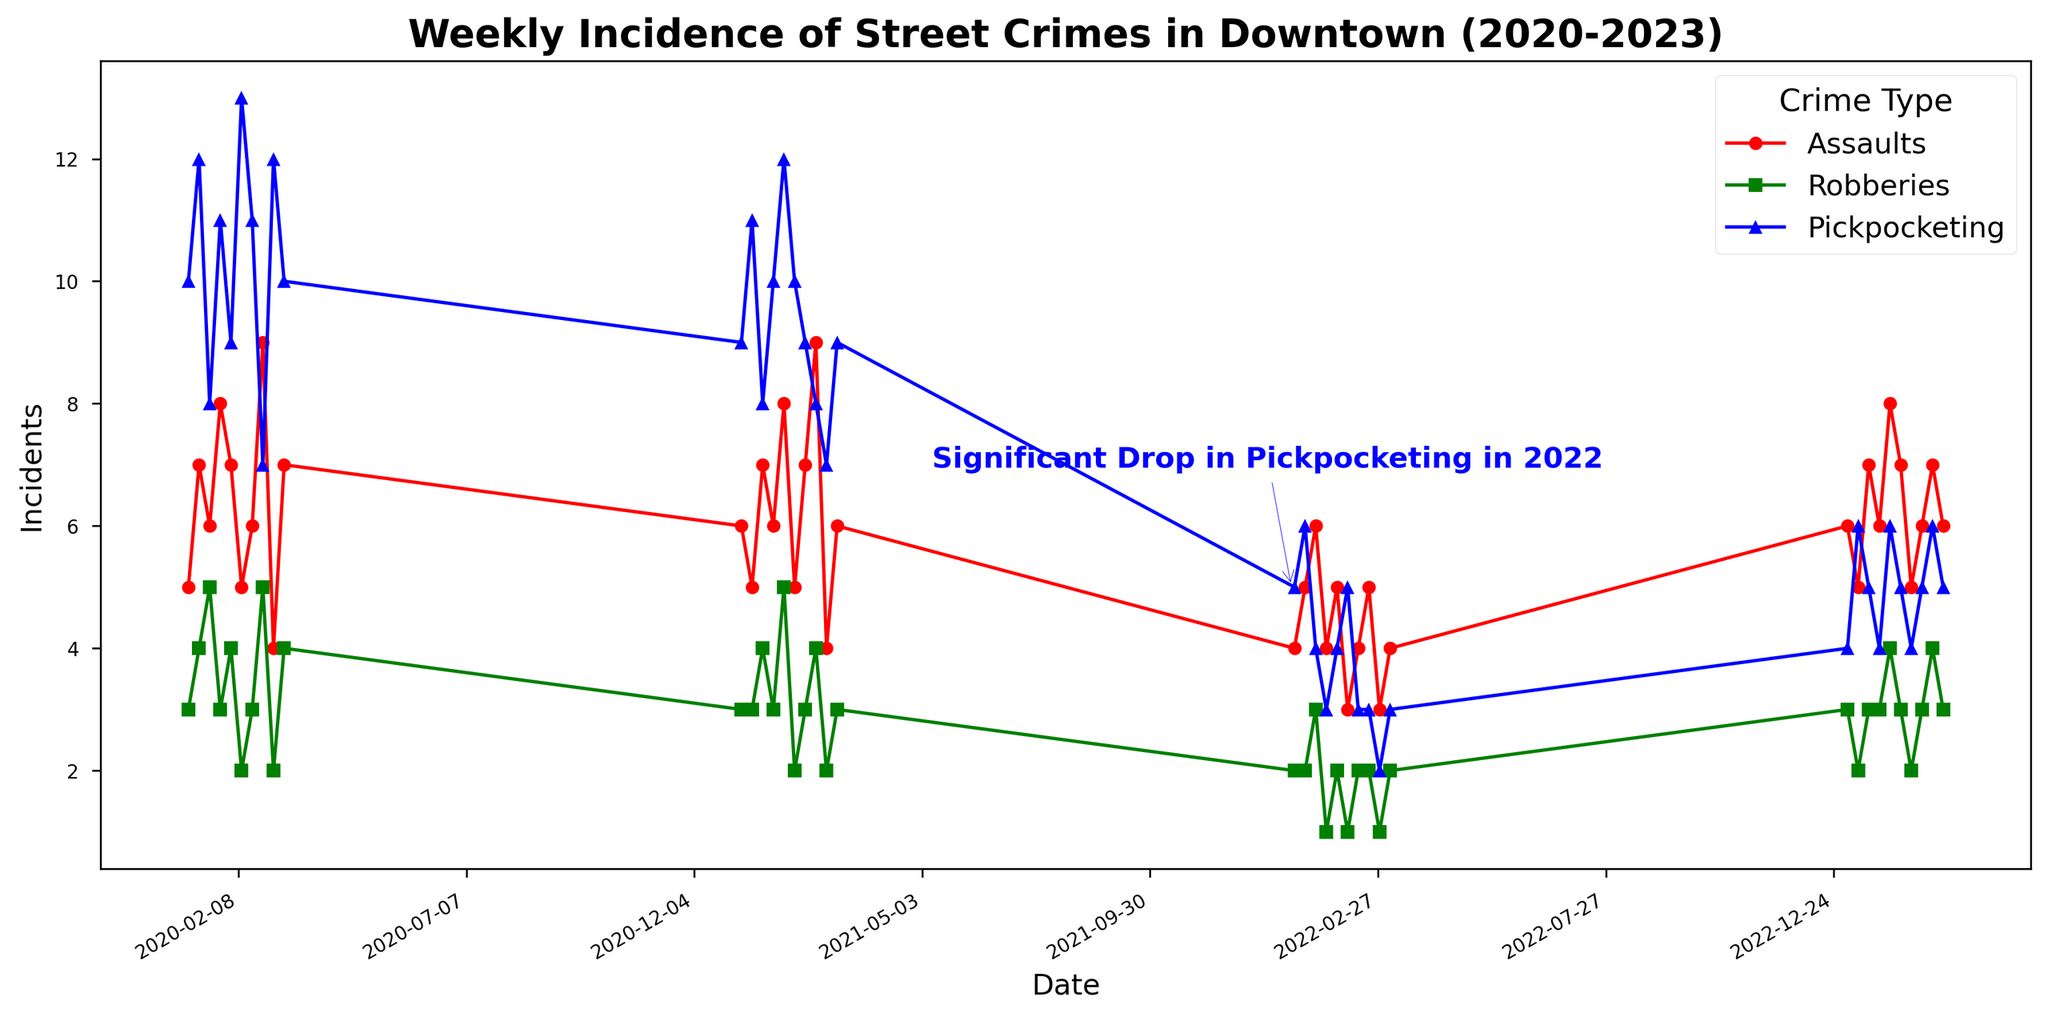Which crime type showed a significant drop in 2022? The chart has an annotation specifically highlighting "Significant Drop in Pickpocketing in 2022" around January 2022 and indicates a noticeable reduction in pickpocket incidents.
Answer: Pickpocketing When did the number of pickpocketing incidents drop to their lowest in 2022? Looking at the "Pickpocketing" line, the lowest point in 2022 occurs around week 9, with incidents dropping to 2.
Answer: Around week 9 (March) How did the number of pickpocketing incidents change from 2021 to 2022? By comparing the "Pickpocketing" line between 2021 and 2022, we observe a sharp decrease, with incidents typically going from higher values (7-12) in 2021 to lower values (2-6) in 2022.
Answer: Decreased significantly Which crime category had the highest average incidents between 2020 and 2023? By visually assessing the average heights of the lines for Assaults, Robberies, and Pickpocketing, it’s evident that "Pickpocketing" had the highest average incidents.
Answer: Pickpocketing In 2023, which crime type experienced the smallest variability in weekly incidents? Evaluating the lines' fluctuations in 2023, "Robberies" shows the smallest variability, with the line remaining relatively flat.
Answer: Robberies How many times in 2022 did the weekly incidents for assaults reach 6 or more? By examining the "Assaults" line, we can see that incidents reached or exceeded 6 at around week 3, week 5, and week 8.
Answer: 3 times Which year had the highest peak in robberies, and approximately when did this occur? The "Robberies" line peaks highest in 2021 at around week 5.
Answer: 2021, around week 5 What was the general trend in pickpocketing incidents from 2020 to 2023? The "Pickpocketing" trend shows high variability in 2020 and 2021, then a sharp decline in 2022, followed by a slight increase but at a generally lower level in 2023.
Answer: Decreasing trend Compare the average weekly incidents of assaults in 2021 to those in 2022. By visually comparing the line heights, assaults in 2021 typically stay between 4-9, whereas in 2022, they are more around 3-6. On average, assaults appear higher in 2021 than in 2022.
Answer: Higher in 2021 